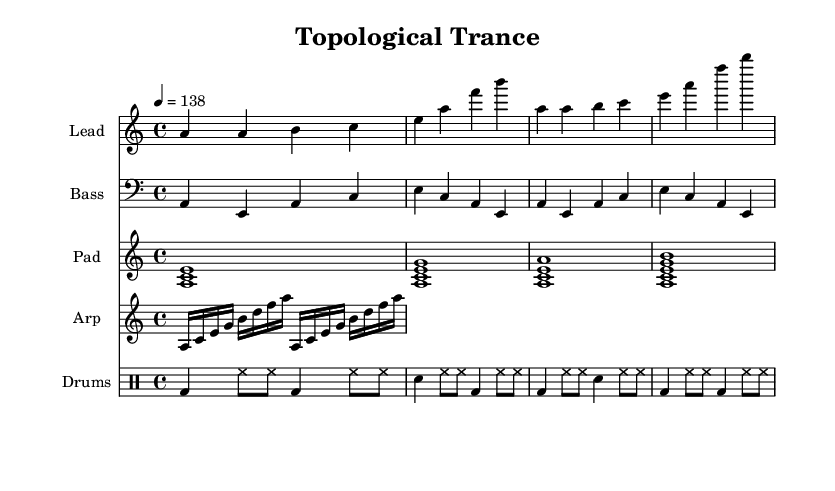What is the key signature of this music? The key signature is A minor, which contains no sharps or flats. It can be identified from the beginning of the music sheet where the key is indicated.
Answer: A minor What is the time signature of this piece? The time signature is 4/4, indicated at the beginning of the score, showing that there are four beats in each measure.
Answer: 4/4 What is the tempo marking for this piece? The tempo marking indicates a speed of 138 beats per minute, as shown by the tempo text at the start of the score.
Answer: 138 How many measures does the lead synth part contain? The lead synth part has 4 measures, as indicated by counting the groupings separated by vertical bar lines in the staff.
Answer: 4 Which instruments are included in this score? The instruments featured in this score include Lead, Bass, Pad, Arp, and Drums, indicated by their respective staff headings.
Answer: Lead, Bass, Pad, Arp, Drums What kind of rhythmic pattern is used in the drum machine part? The drum machine part utilizes a repetitive pattern of bass drum and hi-hat with a snare hit, typical of dance music. This is observed by analyzing the combination of note symbols used.
Answer: Repetitive pattern What is the chord structure presented in the pad synth part? The pad synth primarily uses three-note chords consisting of A minor, A minor 7th, and A minor 9th, which can be derived from the stacked notes indicated throughout the measures.
Answer: A minor, A minor 7th, A minor 9th 